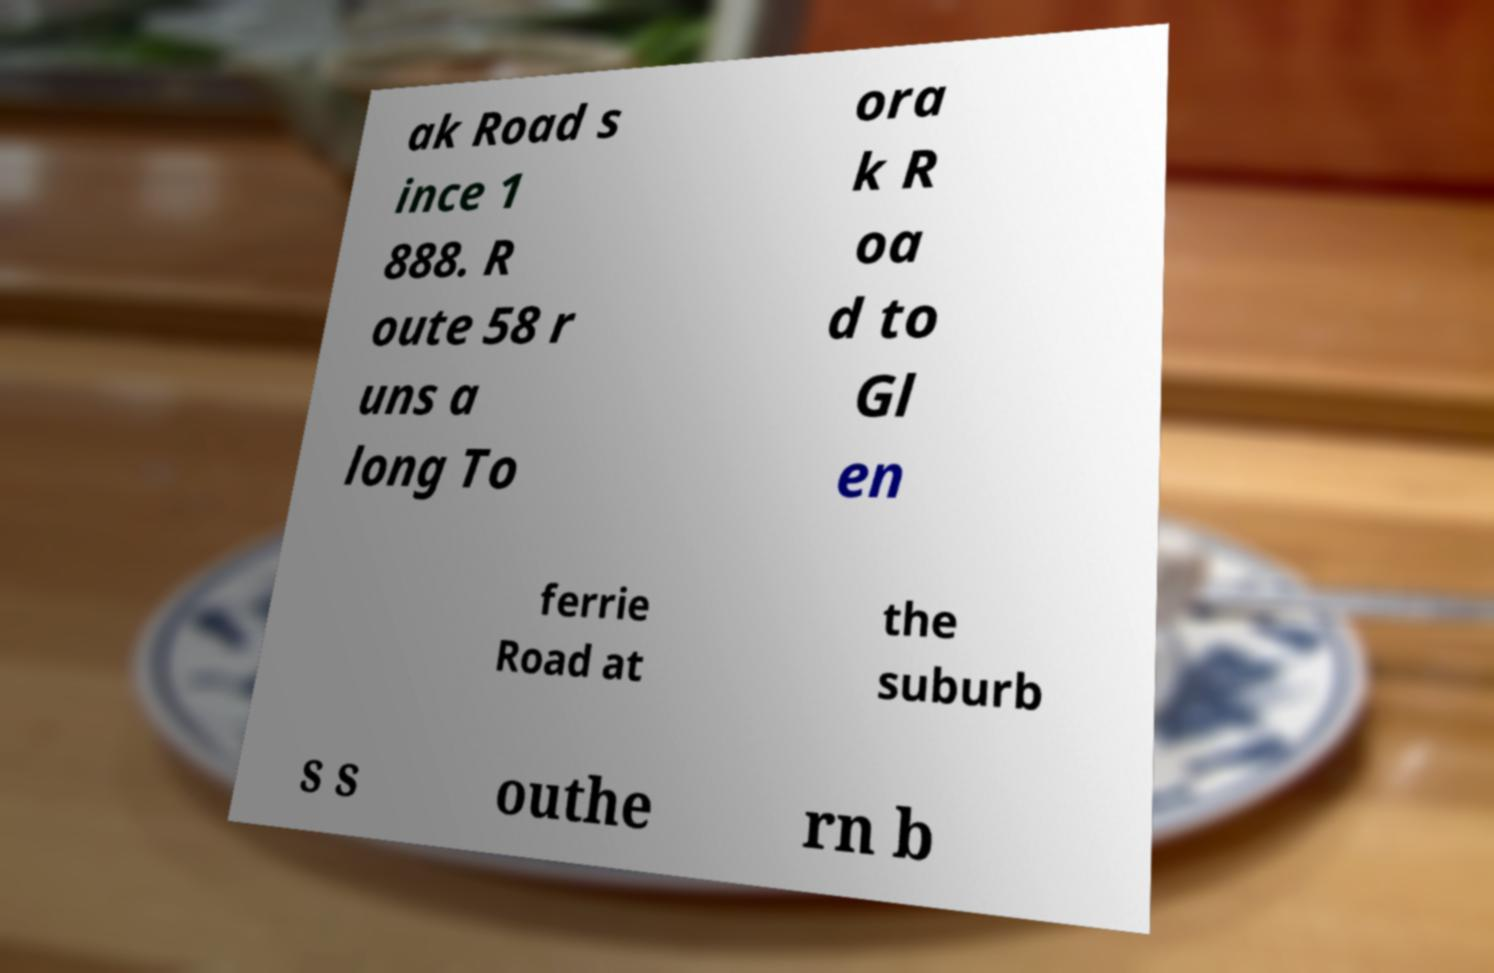Can you read and provide the text displayed in the image?This photo seems to have some interesting text. Can you extract and type it out for me? ak Road s ince 1 888. R oute 58 r uns a long To ora k R oa d to Gl en ferrie Road at the suburb s s outhe rn b 